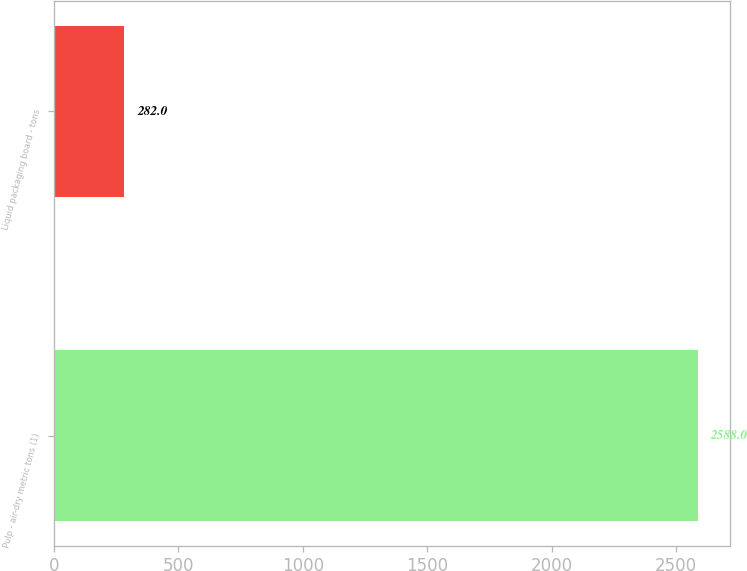Convert chart to OTSL. <chart><loc_0><loc_0><loc_500><loc_500><bar_chart><fcel>Pulp - air-dry metric tons (1)<fcel>Liquid packaging board - tons<nl><fcel>2588<fcel>282<nl></chart> 